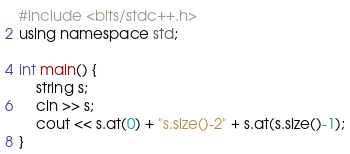<code> <loc_0><loc_0><loc_500><loc_500><_C++_>#include <bits/stdc++.h>
using namespace std;

int main() {
    string s;
    cin >> s;
    cout << s.at(0) + "s.size()-2" + s.at(s.size()-1);
}</code> 